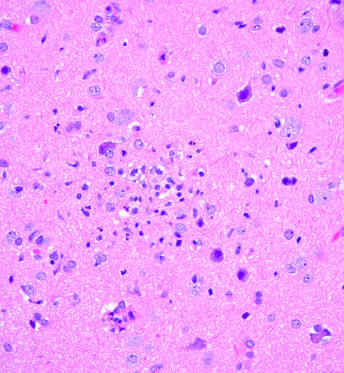did the cysts form a poorly defined nodule?
Answer the question using a single word or phrase. No 